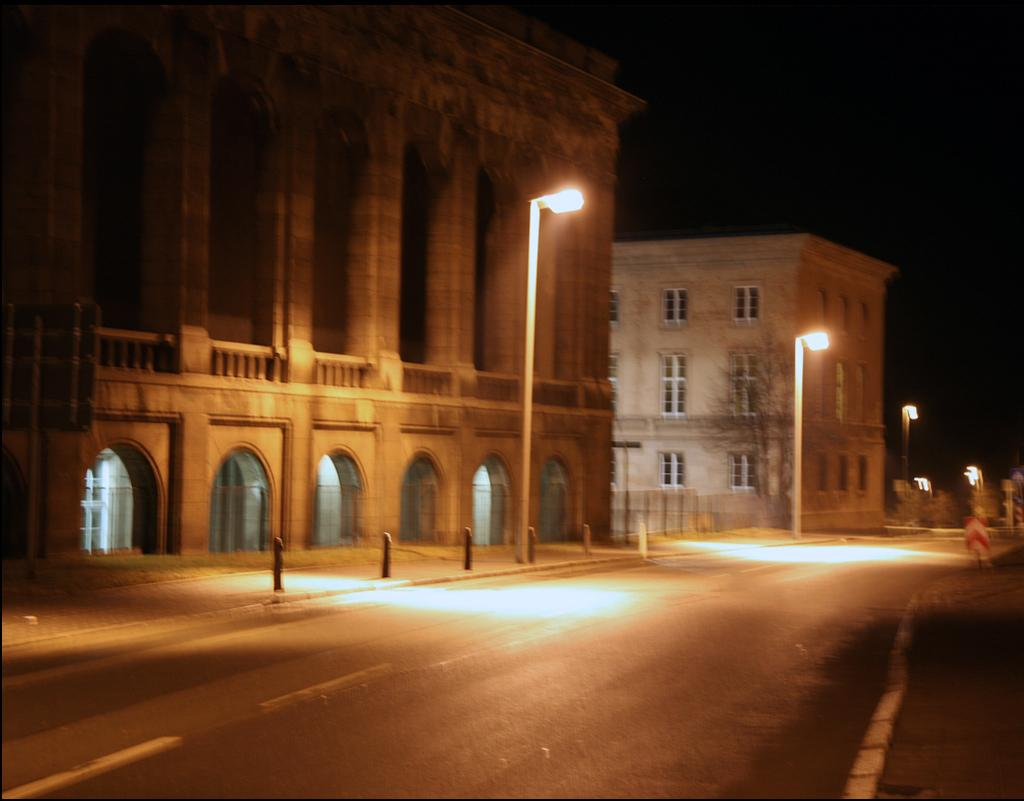What type of structures can be seen in the image? There are buildings in the image. What is located in front of the buildings? Street lights and rods are visible in front of the buildings. What is the surface between the buildings and the street lights? There is a road in front of the buildings. How would you describe the lighting conditions in the image? The background of the image is dark. Can you hear the bell ringing in the image? There is no bell present in the image, so it cannot be heard. 